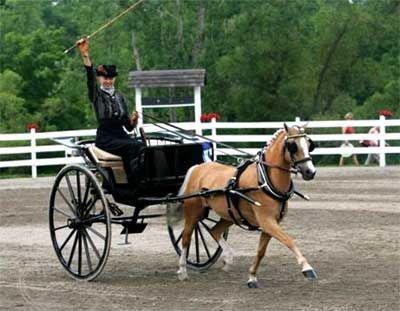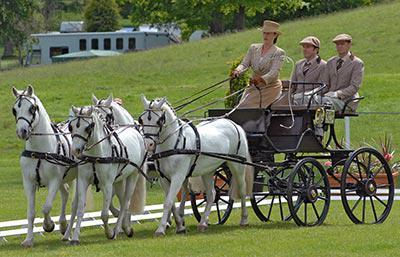The first image is the image on the left, the second image is the image on the right. Considering the images on both sides, is "On each picture, there is a single horse pulling a cart." valid? Answer yes or no. No. The first image is the image on the left, the second image is the image on the right. Considering the images on both sides, is "An image shows a four-wheeled wagon pulled by more than one horse." valid? Answer yes or no. Yes. 